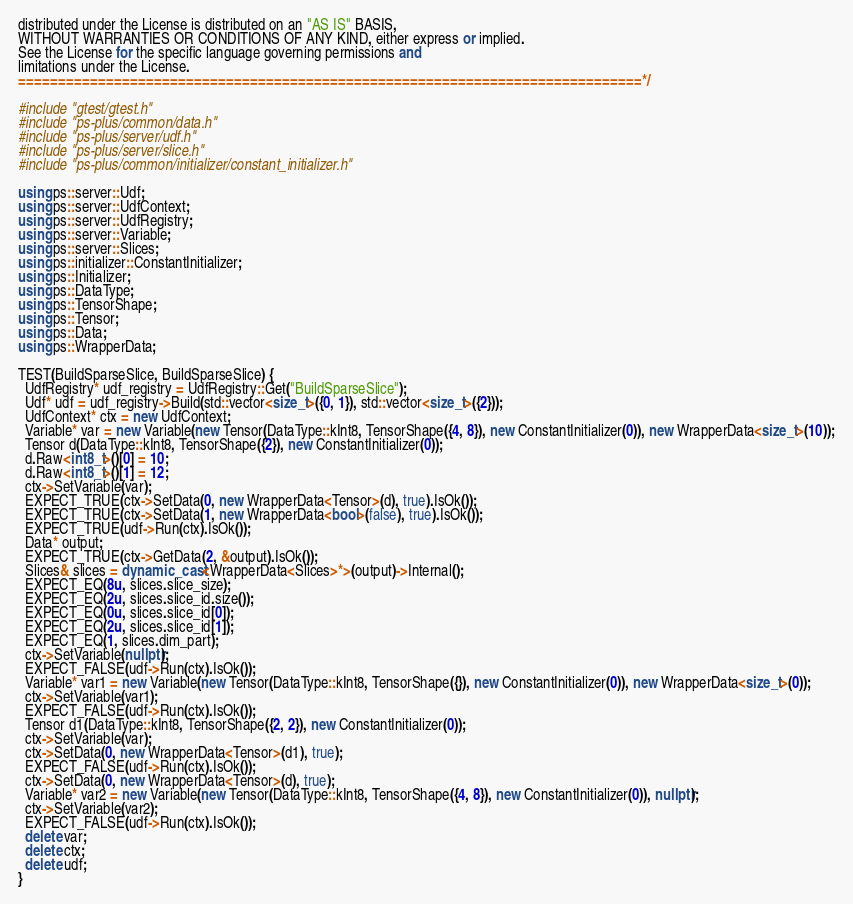<code> <loc_0><loc_0><loc_500><loc_500><_C++_>distributed under the License is distributed on an "AS IS" BASIS,
WITHOUT WARRANTIES OR CONDITIONS OF ANY KIND, either express or implied.
See the License for the specific language governing permissions and
limitations under the License.
==============================================================================*/

#include "gtest/gtest.h"
#include "ps-plus/common/data.h"
#include "ps-plus/server/udf.h"
#include "ps-plus/server/slice.h"
#include "ps-plus/common/initializer/constant_initializer.h"

using ps::server::Udf;
using ps::server::UdfContext;
using ps::server::UdfRegistry;
using ps::server::Variable;
using ps::server::Slices;
using ps::initializer::ConstantInitializer;
using ps::Initializer;
using ps::DataType;
using ps::TensorShape;
using ps::Tensor;
using ps::Data;
using ps::WrapperData;

TEST(BuildSparseSlice, BuildSparseSlice) {
  UdfRegistry* udf_registry = UdfRegistry::Get("BuildSparseSlice");
  Udf* udf = udf_registry->Build(std::vector<size_t>({0, 1}), std::vector<size_t>({2}));
  UdfContext* ctx = new UdfContext;
  Variable* var = new Variable(new Tensor(DataType::kInt8, TensorShape({4, 8}), new ConstantInitializer(0)), new WrapperData<size_t>(10));
  Tensor d(DataType::kInt8, TensorShape({2}), new ConstantInitializer(0));
  d.Raw<int8_t>()[0] = 10;
  d.Raw<int8_t>()[1] = 12;
  ctx->SetVariable(var);
  EXPECT_TRUE(ctx->SetData(0, new WrapperData<Tensor>(d), true).IsOk());
  EXPECT_TRUE(ctx->SetData(1, new WrapperData<bool>(false), true).IsOk());
  EXPECT_TRUE(udf->Run(ctx).IsOk());
  Data* output;
  EXPECT_TRUE(ctx->GetData(2, &output).IsOk());
  Slices& slices = dynamic_cast<WrapperData<Slices>*>(output)->Internal();
  EXPECT_EQ(8u, slices.slice_size);
  EXPECT_EQ(2u, slices.slice_id.size());
  EXPECT_EQ(0u, slices.slice_id[0]);
  EXPECT_EQ(2u, slices.slice_id[1]);
  EXPECT_EQ(1, slices.dim_part);
  ctx->SetVariable(nullptr);
  EXPECT_FALSE(udf->Run(ctx).IsOk());
  Variable* var1 = new Variable(new Tensor(DataType::kInt8, TensorShape({}), new ConstantInitializer(0)), new WrapperData<size_t>(0));
  ctx->SetVariable(var1);
  EXPECT_FALSE(udf->Run(ctx).IsOk());
  Tensor d1(DataType::kInt8, TensorShape({2, 2}), new ConstantInitializer(0));
  ctx->SetVariable(var);
  ctx->SetData(0, new WrapperData<Tensor>(d1), true);
  EXPECT_FALSE(udf->Run(ctx).IsOk());
  ctx->SetData(0, new WrapperData<Tensor>(d), true);
  Variable* var2 = new Variable(new Tensor(DataType::kInt8, TensorShape({4, 8}), new ConstantInitializer(0)), nullptr);
  ctx->SetVariable(var2);
  EXPECT_FALSE(udf->Run(ctx).IsOk());
  delete var;
  delete ctx;
  delete udf;
}

</code> 